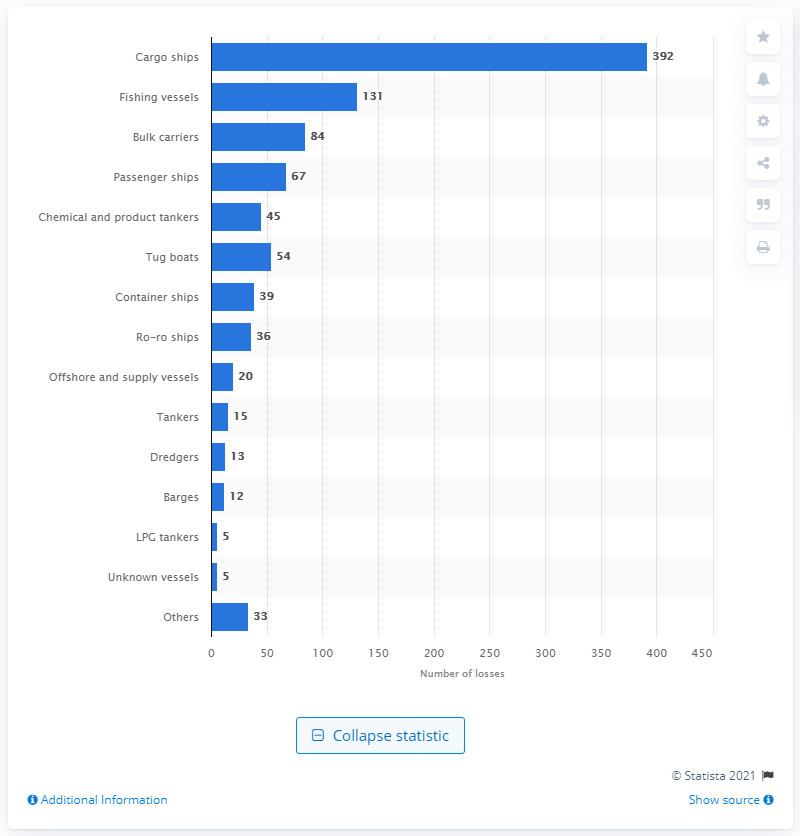Indicate a few pertinent items in this graphic. During the period of 2010 to 2019, there were 54 reported losses of tug boats. 